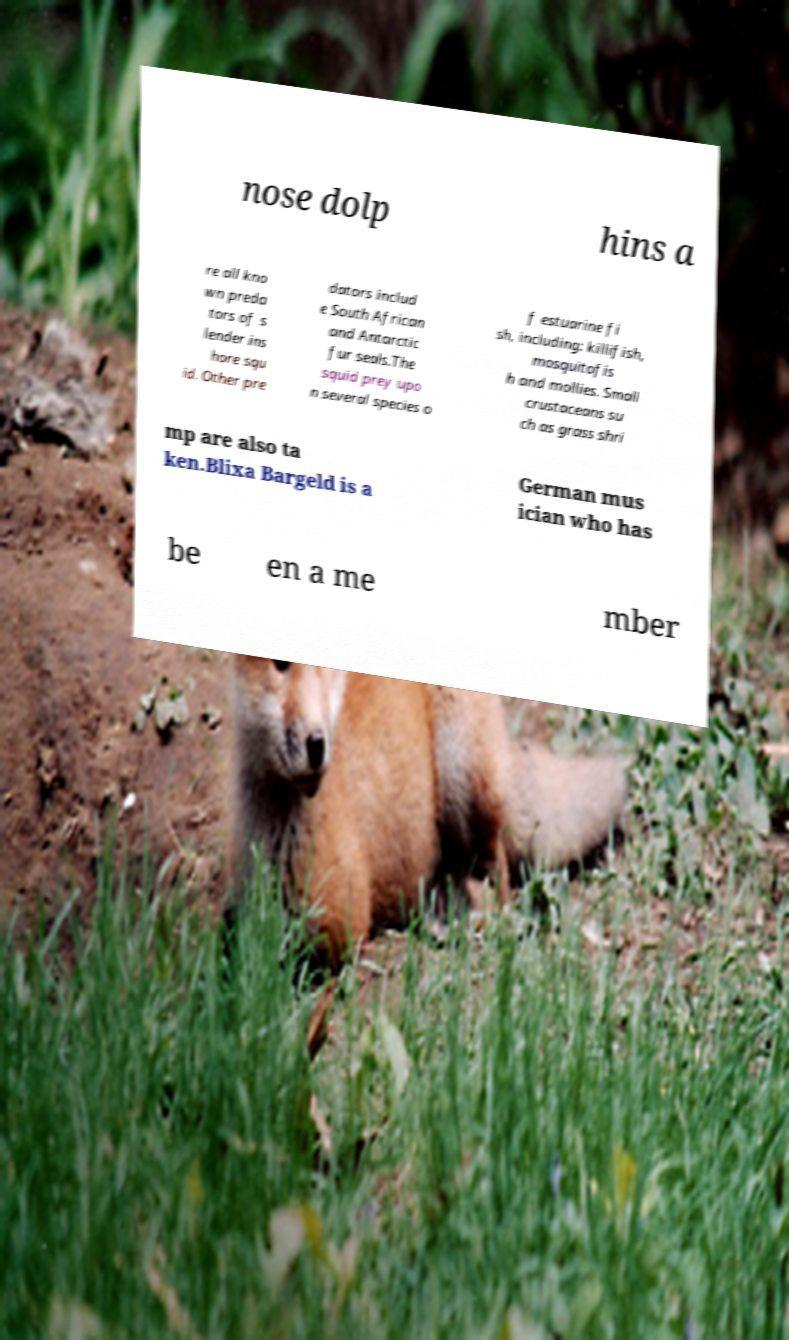For documentation purposes, I need the text within this image transcribed. Could you provide that? nose dolp hins a re all kno wn preda tors of s lender ins hore squ id. Other pre dators includ e South African and Antarctic fur seals.The squid prey upo n several species o f estuarine fi sh, including: killifish, mosquitofis h and mollies. Small crustaceans su ch as grass shri mp are also ta ken.Blixa Bargeld is a German mus ician who has be en a me mber 